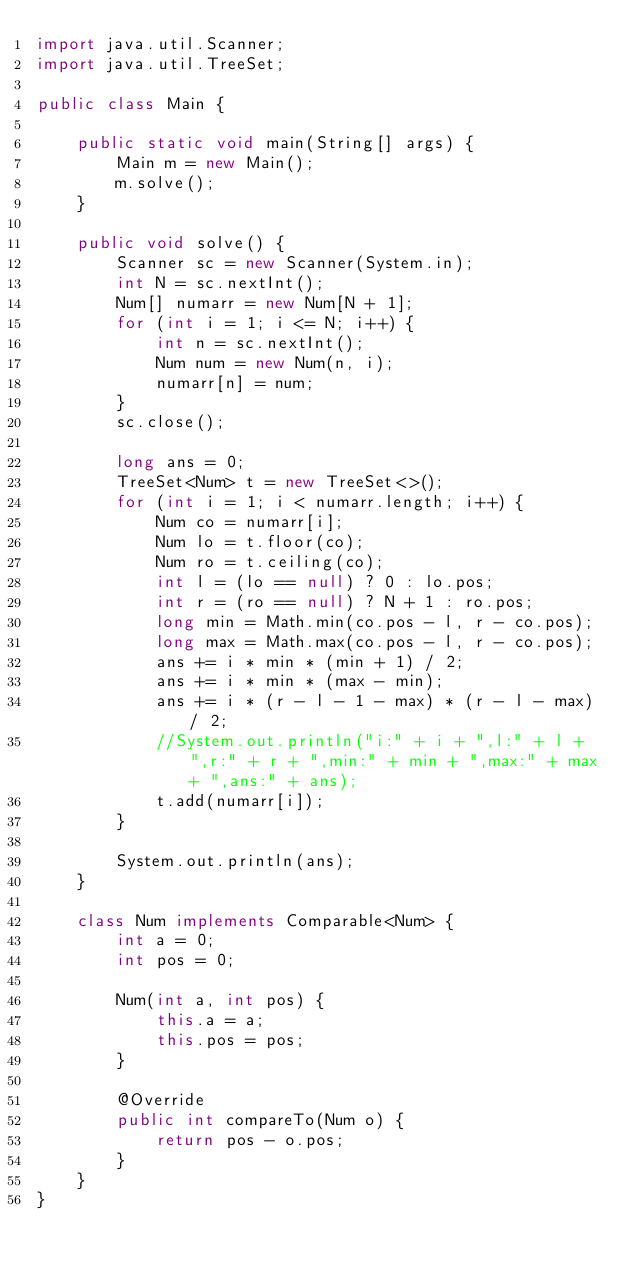<code> <loc_0><loc_0><loc_500><loc_500><_Java_>import java.util.Scanner;
import java.util.TreeSet;

public class Main {

	public static void main(String[] args) {
		Main m = new Main();
		m.solve();
	}

	public void solve() {
		Scanner sc = new Scanner(System.in);
		int N = sc.nextInt();
		Num[] numarr = new Num[N + 1];
		for (int i = 1; i <= N; i++) {
			int n = sc.nextInt();
			Num num = new Num(n, i);
			numarr[n] = num;
		}
		sc.close();

		long ans = 0;
		TreeSet<Num> t = new TreeSet<>();
		for (int i = 1; i < numarr.length; i++) {
			Num co = numarr[i];
			Num lo = t.floor(co);
			Num ro = t.ceiling(co);
			int l = (lo == null) ? 0 : lo.pos;
			int r = (ro == null) ? N + 1 : ro.pos;
			long min = Math.min(co.pos - l, r - co.pos);
			long max = Math.max(co.pos - l, r - co.pos);
			ans += i * min * (min + 1) / 2;
			ans += i * min * (max - min);
			ans += i * (r - l - 1 - max) * (r - l - max) / 2;
			//System.out.println("i:" + i + ",l:" + l + ",r:" + r + ",min:" + min + ",max:" + max + ",ans:" + ans);
			t.add(numarr[i]);
		}

		System.out.println(ans);
	}

	class Num implements Comparable<Num> {
		int a = 0;
		int pos = 0;

		Num(int a, int pos) {
			this.a = a;
			this.pos = pos;
		}

		@Override
		public int compareTo(Num o) {
			return pos - o.pos;
		}
	}
}
</code> 